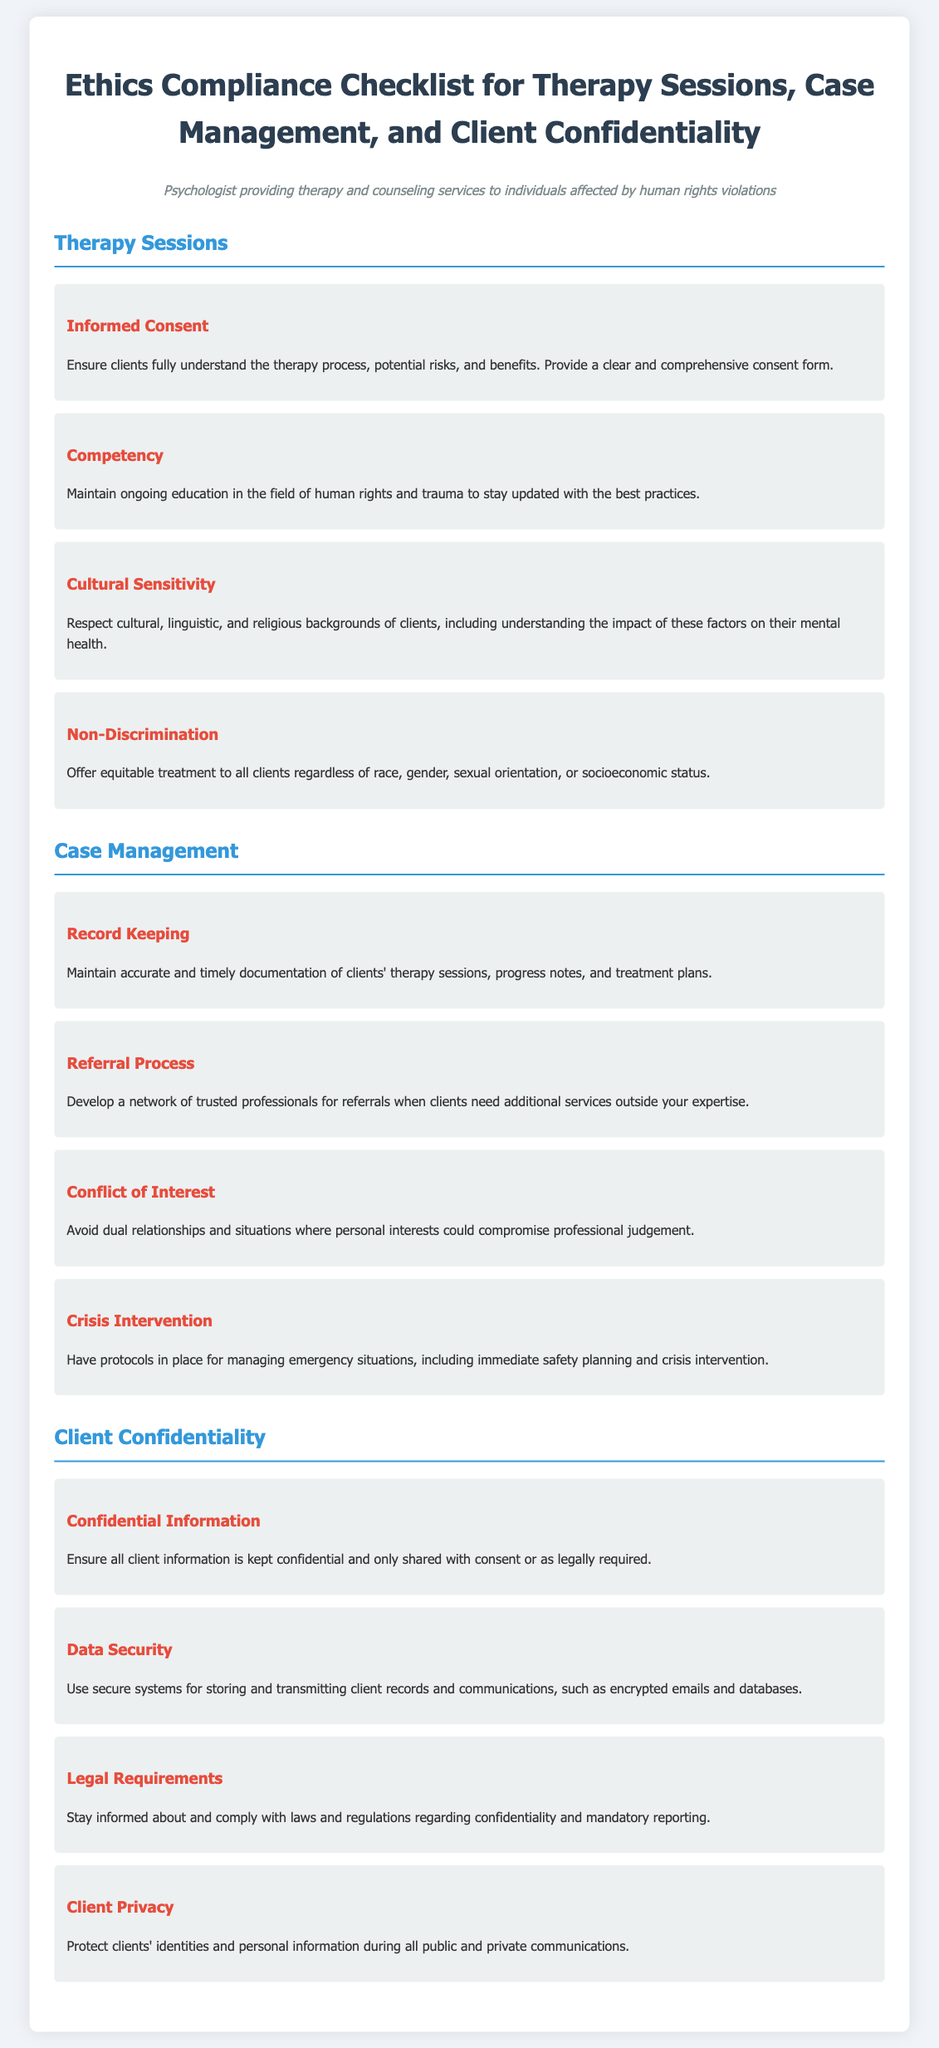What is the primary focus of this checklist? The primary focus of this checklist is adherence to ethical guidelines in therapy sessions, case management, and client confidentiality.
Answer: adherence to ethical guidelines What must be ensured regarding informed consent? It must be ensured that clients fully understand the therapy process, potential risks, and benefits.
Answer: clients fully understand What type of treatment should be offered to clients? Equitable treatment should be offered regardless of race, gender, sexual orientation, or socioeconomic status.
Answer: equitable treatment What should be maintained regarding client documentation? Accurate and timely documentation of clients' therapy sessions, progress notes, and treatment plans should be maintained.
Answer: accurate and timely documentation What is crucial when developing a referral process? It is crucial to develop a network of trusted professionals for referrals.
Answer: network of trusted professionals What must be ensured about client information? It must be ensured that all client information is kept confidential.
Answer: kept confidential What should be used for securing client records? Secure systems such as encrypted emails and databases should be used for storing and transmitting client records.
Answer: secure systems What is required for crisis intervention? Protocols for managing emergency situations are required.
Answer: protocols for emergency situations What must be protected during communications? Clients' identities and personal information must be protected during all public and private communications.
Answer: protected identities and information 